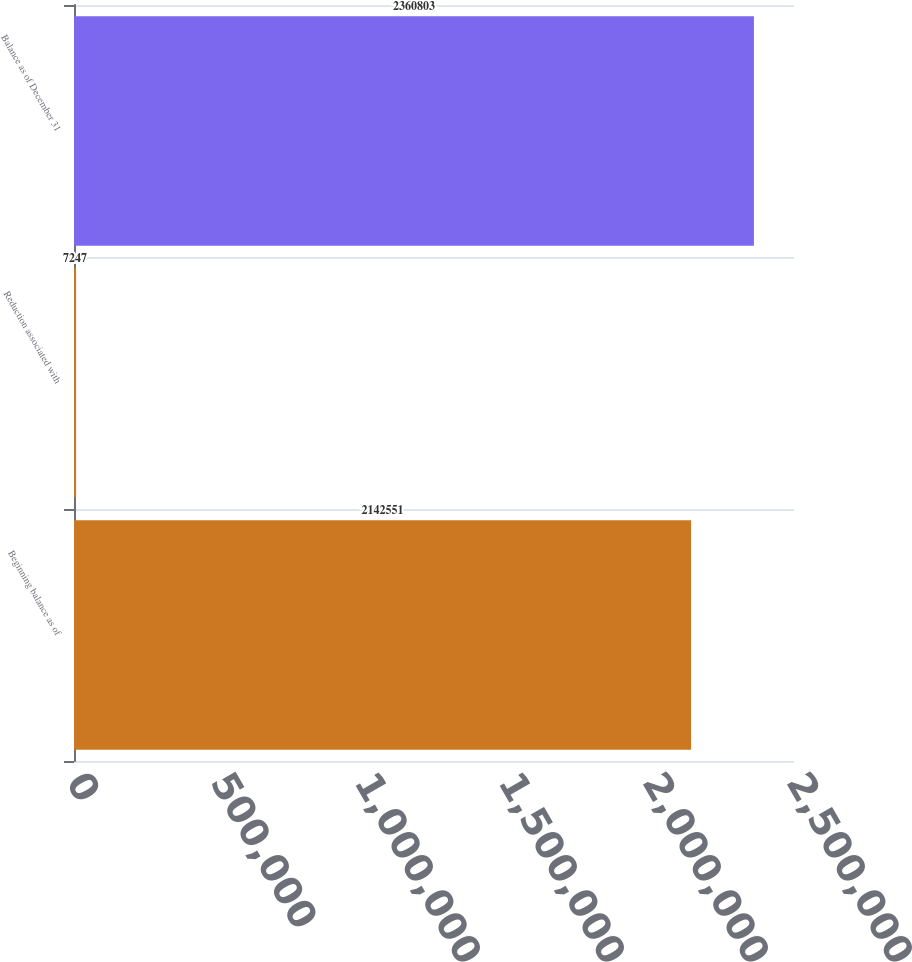Convert chart. <chart><loc_0><loc_0><loc_500><loc_500><bar_chart><fcel>Beginning balance as of<fcel>Reduction associated with<fcel>Balance as of December 31<nl><fcel>2.14255e+06<fcel>7247<fcel>2.3608e+06<nl></chart> 